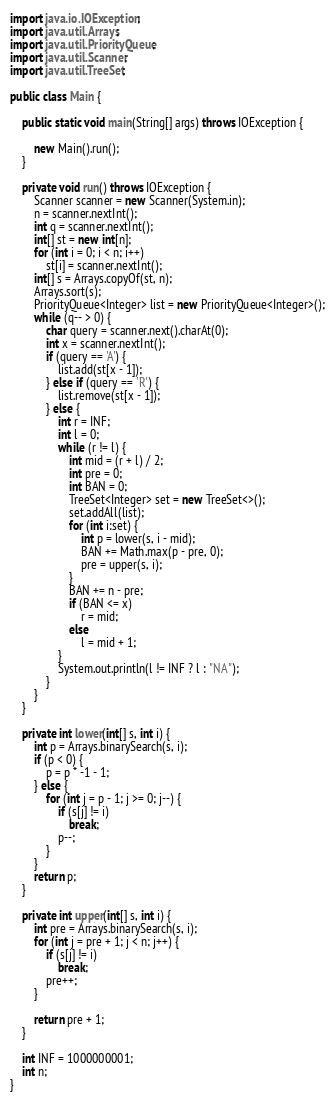<code> <loc_0><loc_0><loc_500><loc_500><_Java_>
import java.io.IOException;
import java.util.Arrays;
import java.util.PriorityQueue;
import java.util.Scanner;
import java.util.TreeSet;

public class Main {

	public static void main(String[] args) throws IOException {

		new Main().run();
	}

	private void run() throws IOException {
		Scanner scanner = new Scanner(System.in);
		n = scanner.nextInt();
		int q = scanner.nextInt();
		int[] st = new int[n];
		for (int i = 0; i < n; i++)
			st[i] = scanner.nextInt();
		int[] s = Arrays.copyOf(st, n);
		Arrays.sort(s);
		PriorityQueue<Integer> list = new PriorityQueue<Integer>();
		while (q-- > 0) {
			char query = scanner.next().charAt(0);
			int x = scanner.nextInt();
			if (query == 'A') {
				list.add(st[x - 1]);
			} else if (query == 'R') {
				list.remove(st[x - 1]);
			} else {
				int r = INF;
				int l = 0;
				while (r != l) {
					int mid = (r + l) / 2;
					int pre = 0;
					int BAN = 0;
					TreeSet<Integer> set = new TreeSet<>();
					set.addAll(list);
					for (int i:set) {
						int p = lower(s, i - mid);
						BAN += Math.max(p - pre, 0);
						pre = upper(s, i);
					}
					BAN += n - pre;
					if (BAN <= x)
						r = mid;
					else
						l = mid + 1;
				}
				System.out.println(l != INF ? l : "NA");
			}
		}
	}

	private int lower(int[] s, int i) {
		int p = Arrays.binarySearch(s, i);
		if (p < 0) {
			p = p * -1 - 1;
		} else {
			for (int j = p - 1; j >= 0; j--) {
				if (s[j] != i)
					break;
				p--;
			}
		}
		return p;
	}

	private int upper(int[] s, int i) {
		int pre = Arrays.binarySearch(s, i);
		for (int j = pre + 1; j < n; j++) {
			if (s[j] != i)
				break;
			pre++;
		}

		return pre + 1;
	}

	int INF = 1000000001;
	int n;
}</code> 